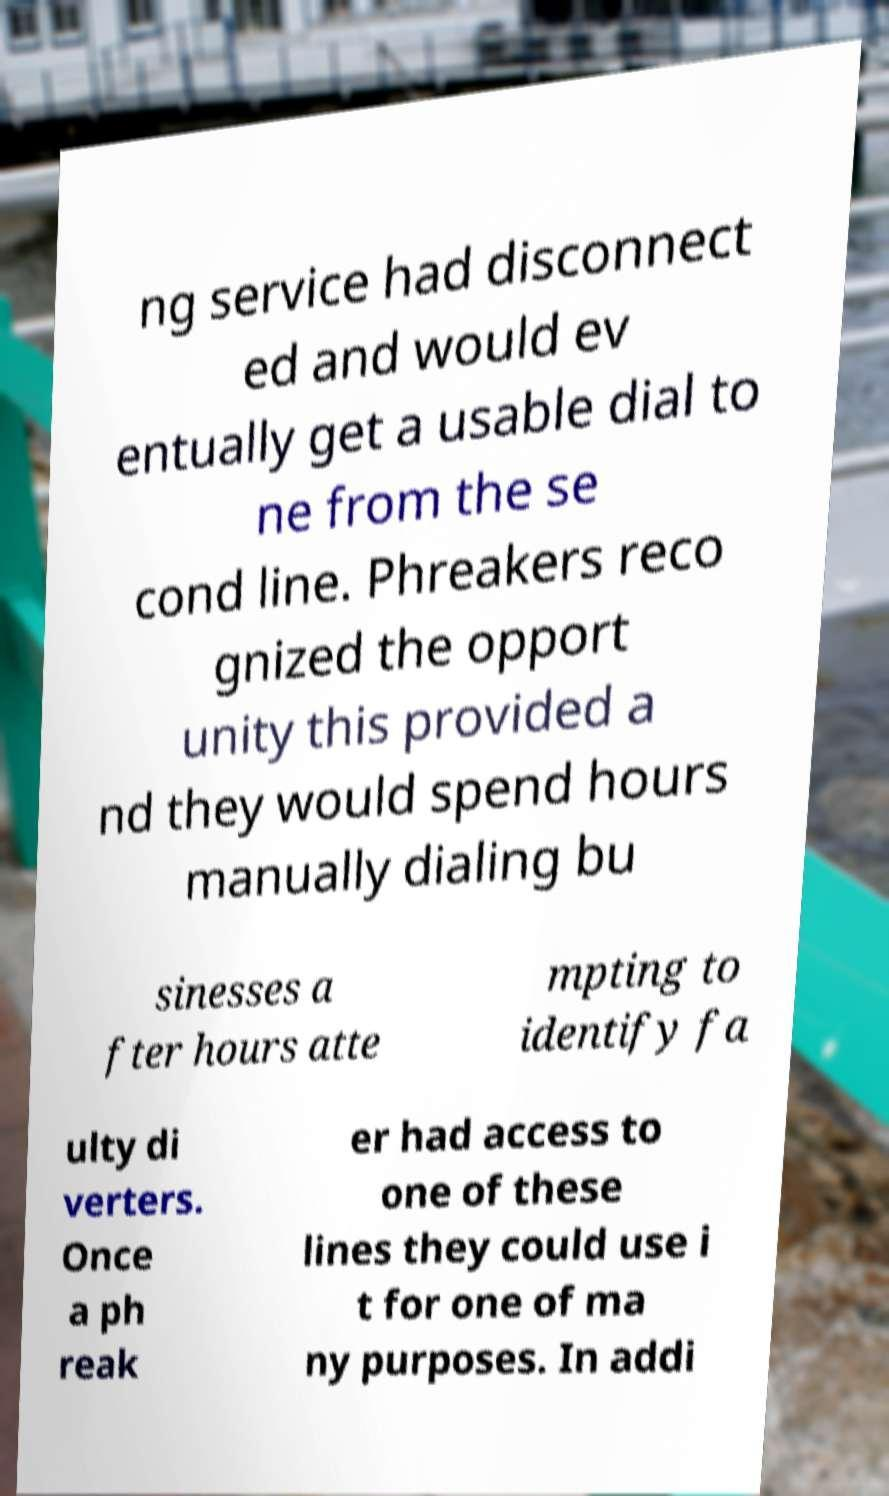Can you read and provide the text displayed in the image?This photo seems to have some interesting text. Can you extract and type it out for me? ng service had disconnect ed and would ev entually get a usable dial to ne from the se cond line. Phreakers reco gnized the opport unity this provided a nd they would spend hours manually dialing bu sinesses a fter hours atte mpting to identify fa ulty di verters. Once a ph reak er had access to one of these lines they could use i t for one of ma ny purposes. In addi 